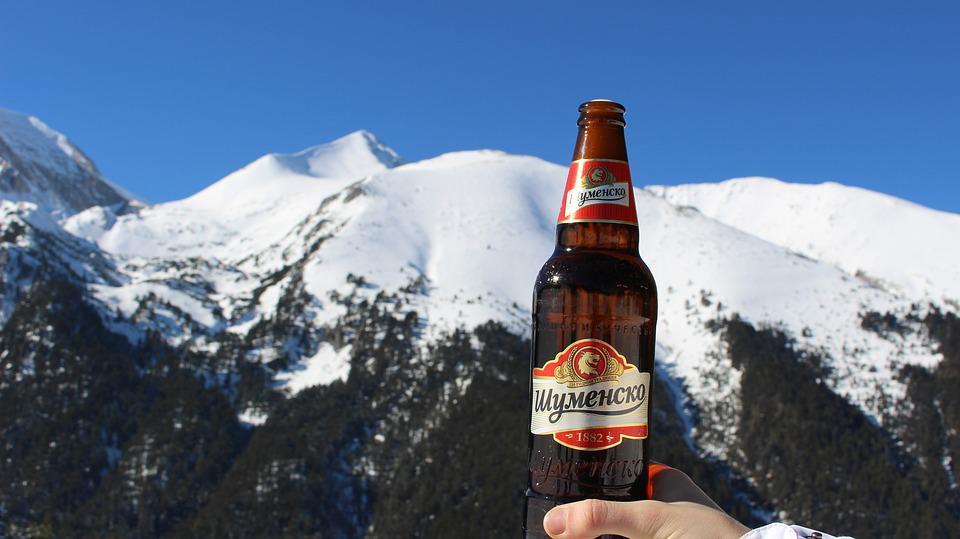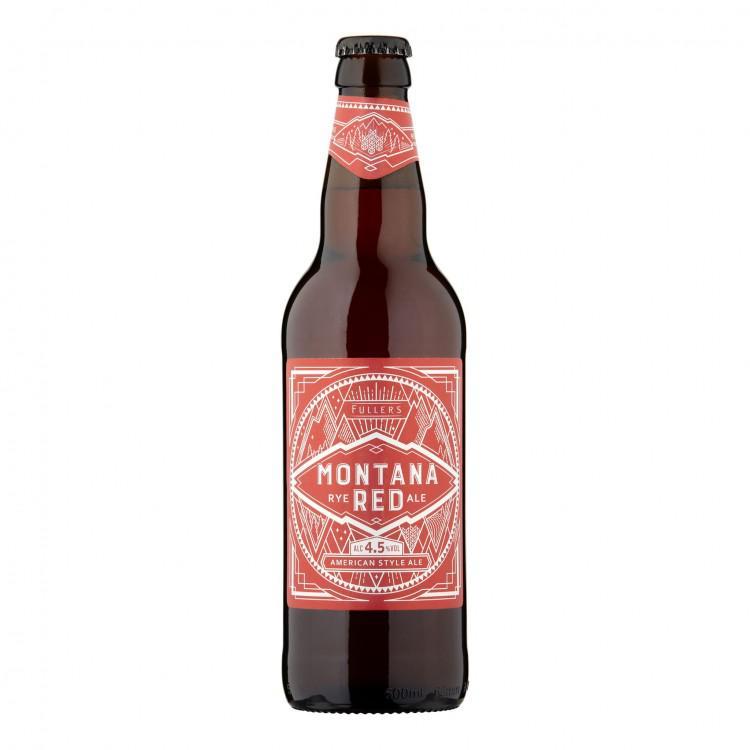The first image is the image on the left, the second image is the image on the right. Evaluate the accuracy of this statement regarding the images: "One of the images shows exactly two bottles of beer.". Is it true? Answer yes or no. No. The first image is the image on the left, the second image is the image on the right. Given the left and right images, does the statement "All bottles have labels on the neck and the body." hold true? Answer yes or no. Yes. 